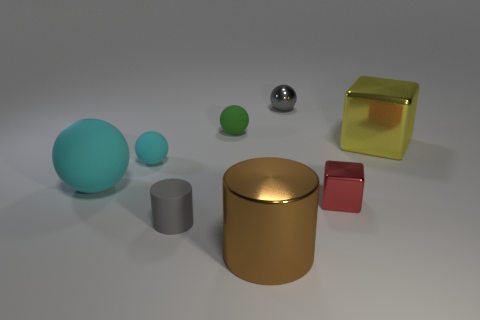How many objects are there in total? There are a total of six objects in the image, including spheres of varying sizes, a cylinder, a cube, and what appears to be a cuboid with a transparent surface. What materials do the objects appear to be made from? The objects in the image seem to have a variety of materials: the spheres and cylinder have a matte finish suggesting rubber or plastic; the shiny sphere seems to be metallic; and the cube and cuboid appear to have glass or transparent plastic surfaces. 